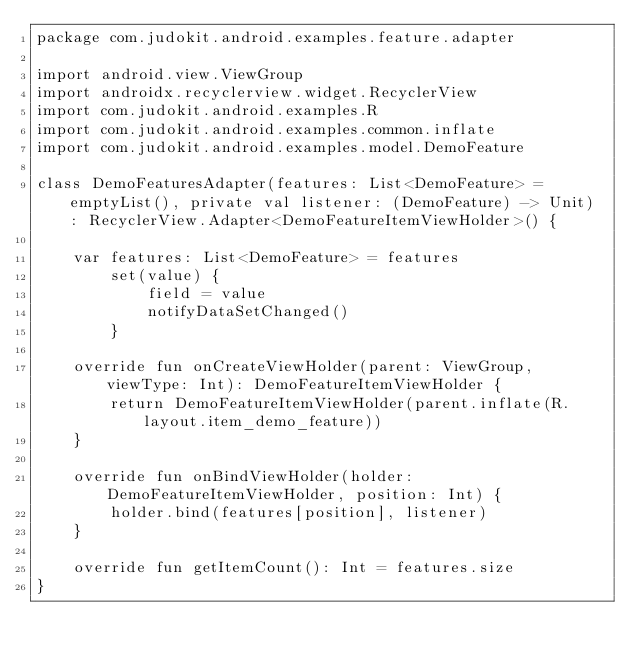Convert code to text. <code><loc_0><loc_0><loc_500><loc_500><_Kotlin_>package com.judokit.android.examples.feature.adapter

import android.view.ViewGroup
import androidx.recyclerview.widget.RecyclerView
import com.judokit.android.examples.R
import com.judokit.android.examples.common.inflate
import com.judokit.android.examples.model.DemoFeature

class DemoFeaturesAdapter(features: List<DemoFeature> = emptyList(), private val listener: (DemoFeature) -> Unit) : RecyclerView.Adapter<DemoFeatureItemViewHolder>() {

    var features: List<DemoFeature> = features
        set(value) {
            field = value
            notifyDataSetChanged()
        }

    override fun onCreateViewHolder(parent: ViewGroup, viewType: Int): DemoFeatureItemViewHolder {
        return DemoFeatureItemViewHolder(parent.inflate(R.layout.item_demo_feature))
    }

    override fun onBindViewHolder(holder: DemoFeatureItemViewHolder, position: Int) {
        holder.bind(features[position], listener)
    }

    override fun getItemCount(): Int = features.size
}
</code> 